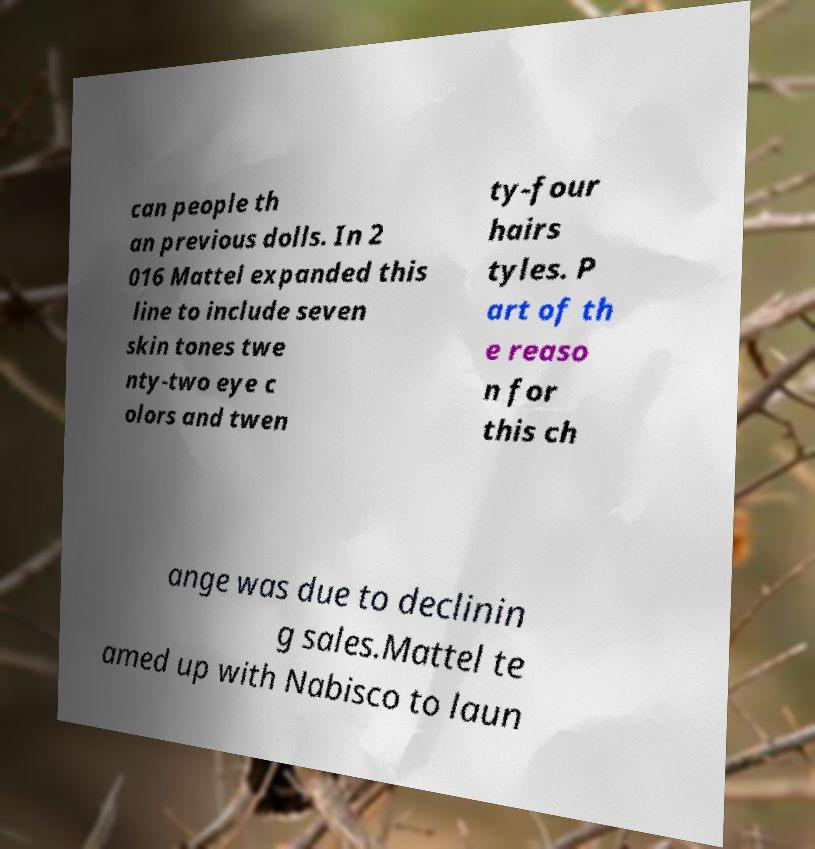Can you read and provide the text displayed in the image?This photo seems to have some interesting text. Can you extract and type it out for me? can people th an previous dolls. In 2 016 Mattel expanded this line to include seven skin tones twe nty-two eye c olors and twen ty-four hairs tyles. P art of th e reaso n for this ch ange was due to declinin g sales.Mattel te amed up with Nabisco to laun 